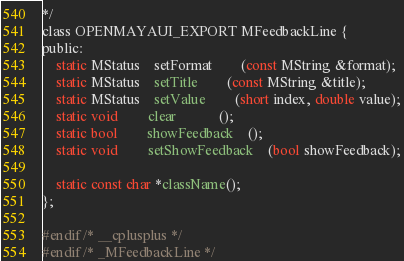Convert code to text. <code><loc_0><loc_0><loc_500><loc_500><_C_>*/
class OPENMAYAUI_EXPORT MFeedbackLine {
public:
	static MStatus	setFormat		(const MString &format);
	static MStatus	setTitle		(const MString &title);
	static MStatus	setValue		(short index, double value);
	static void		clear			();
	static bool		showFeedback	();
	static void		setShowFeedback	(bool showFeedback);

	static const char *className();
};

#endif /* __cplusplus */
#endif /* _MFeedbackLine */
</code> 